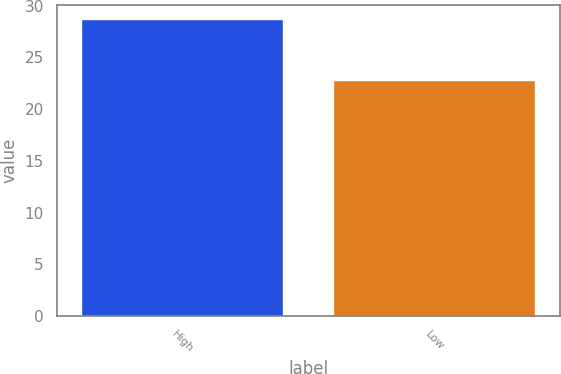Convert chart to OTSL. <chart><loc_0><loc_0><loc_500><loc_500><bar_chart><fcel>High<fcel>Low<nl><fcel>28.64<fcel>22.7<nl></chart> 